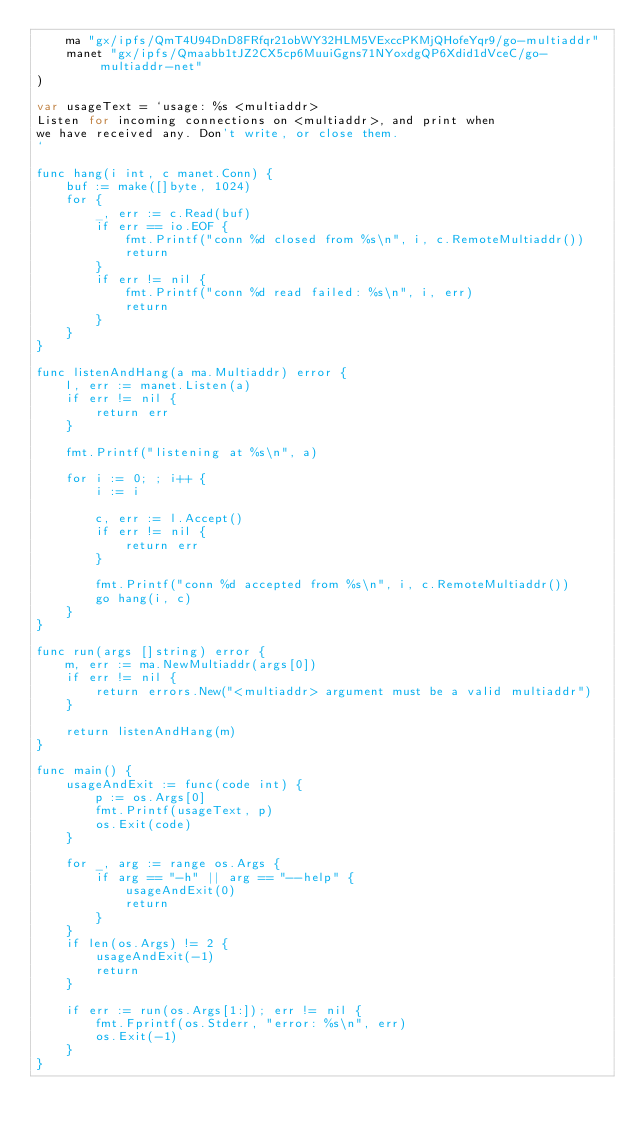<code> <loc_0><loc_0><loc_500><loc_500><_Go_>	ma "gx/ipfs/QmT4U94DnD8FRfqr21obWY32HLM5VExccPKMjQHofeYqr9/go-multiaddr"
	manet "gx/ipfs/Qmaabb1tJZ2CX5cp6MuuiGgns71NYoxdgQP6Xdid1dVceC/go-multiaddr-net"
)

var usageText = `usage: %s <multiaddr>
Listen for incoming connections on <multiaddr>, and print when
we have received any. Don't write, or close them.
`

func hang(i int, c manet.Conn) {
	buf := make([]byte, 1024)
	for {
		_, err := c.Read(buf)
		if err == io.EOF {
			fmt.Printf("conn %d closed from %s\n", i, c.RemoteMultiaddr())
			return
		}
		if err != nil {
			fmt.Printf("conn %d read failed: %s\n", i, err)
			return
		}
	}
}

func listenAndHang(a ma.Multiaddr) error {
	l, err := manet.Listen(a)
	if err != nil {
		return err
	}

	fmt.Printf("listening at %s\n", a)

	for i := 0; ; i++ {
		i := i

		c, err := l.Accept()
		if err != nil {
			return err
		}

		fmt.Printf("conn %d accepted from %s\n", i, c.RemoteMultiaddr())
		go hang(i, c)
	}
}

func run(args []string) error {
	m, err := ma.NewMultiaddr(args[0])
	if err != nil {
		return errors.New("<multiaddr> argument must be a valid multiaddr")
	}

	return listenAndHang(m)
}

func main() {
	usageAndExit := func(code int) {
		p := os.Args[0]
		fmt.Printf(usageText, p)
		os.Exit(code)
	}

	for _, arg := range os.Args {
		if arg == "-h" || arg == "--help" {
			usageAndExit(0)
			return
		}
	}
	if len(os.Args) != 2 {
		usageAndExit(-1)
		return
	}

	if err := run(os.Args[1:]); err != nil {
		fmt.Fprintf(os.Stderr, "error: %s\n", err)
		os.Exit(-1)
	}
}
</code> 